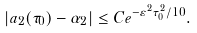Convert formula to latex. <formula><loc_0><loc_0><loc_500><loc_500>| a _ { 2 } ( \tau _ { 0 } ) - \alpha _ { 2 } | \leq C e ^ { - \varepsilon ^ { 2 } \tau _ { 0 } ^ { 2 } / 1 0 } .</formula> 